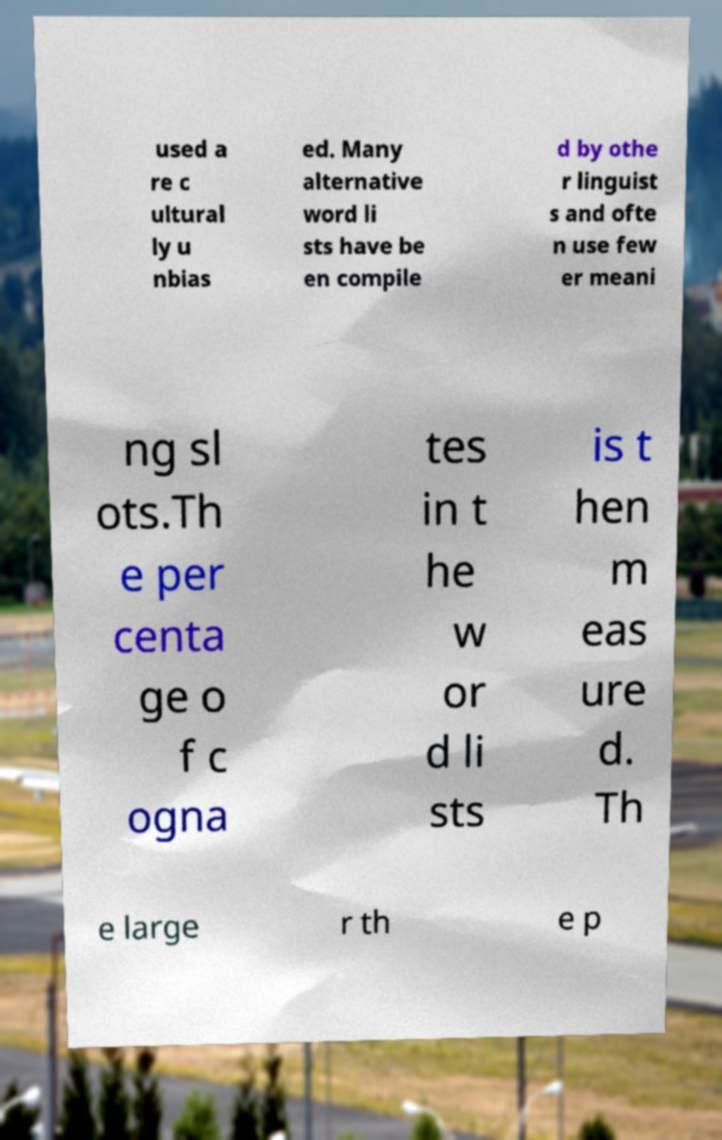Can you read and provide the text displayed in the image?This photo seems to have some interesting text. Can you extract and type it out for me? used a re c ultural ly u nbias ed. Many alternative word li sts have be en compile d by othe r linguist s and ofte n use few er meani ng sl ots.Th e per centa ge o f c ogna tes in t he w or d li sts is t hen m eas ure d. Th e large r th e p 